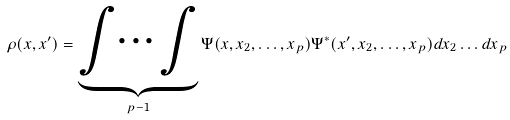Convert formula to latex. <formula><loc_0><loc_0><loc_500><loc_500>\rho ( x , x ^ { \prime } ) = \underbrace { \int \dots \int } _ { p - 1 } \Psi ( x , x _ { 2 } , \dots , x _ { p } ) \Psi ^ { * } ( x ^ { \prime } , x _ { 2 } , \dots , x _ { p } ) d x _ { 2 } \dots d x _ { p }</formula> 